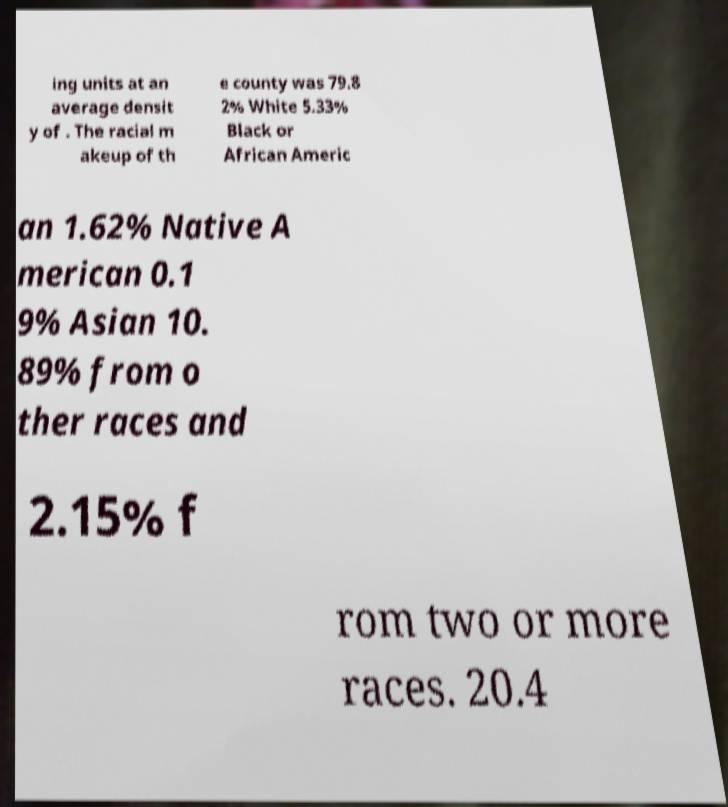Could you extract and type out the text from this image? ing units at an average densit y of . The racial m akeup of th e county was 79.8 2% White 5.33% Black or African Americ an 1.62% Native A merican 0.1 9% Asian 10. 89% from o ther races and 2.15% f rom two or more races. 20.4 